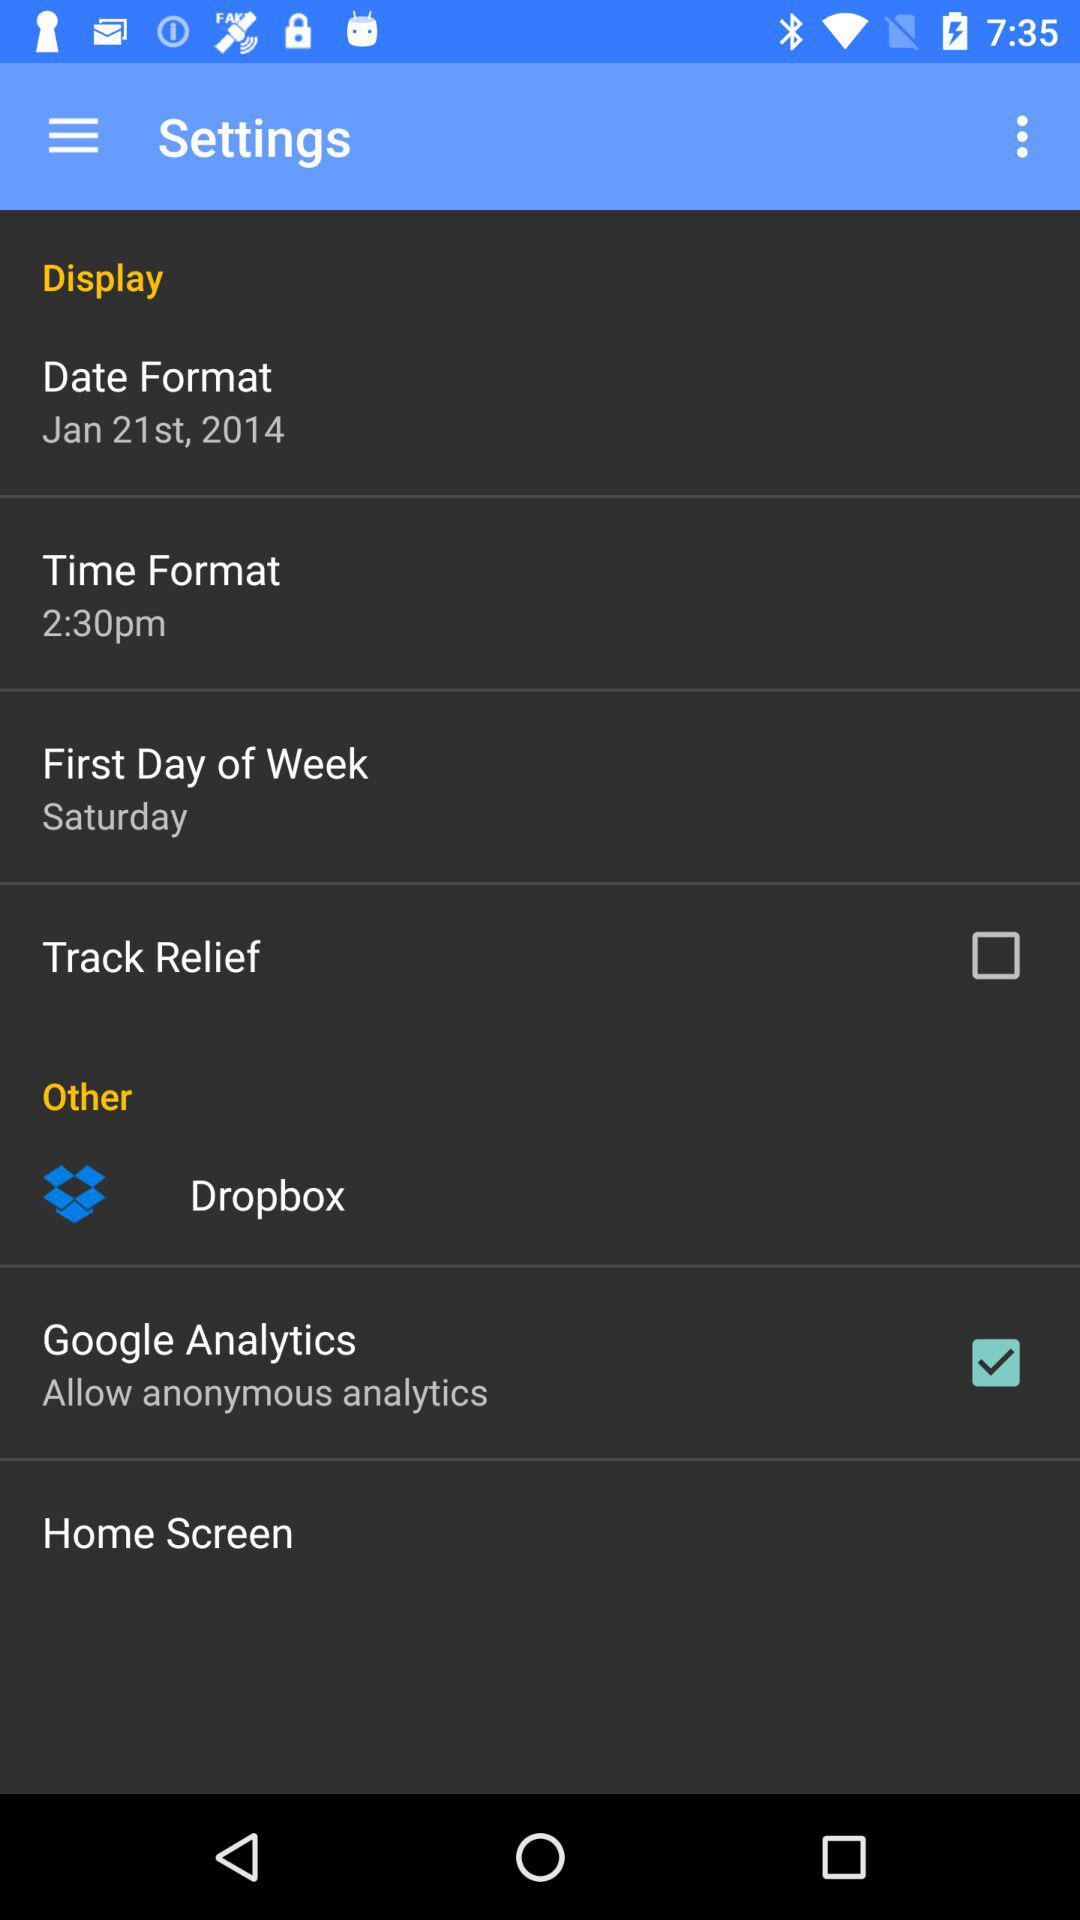What's the status of track relief? The status of track relief is "off". 